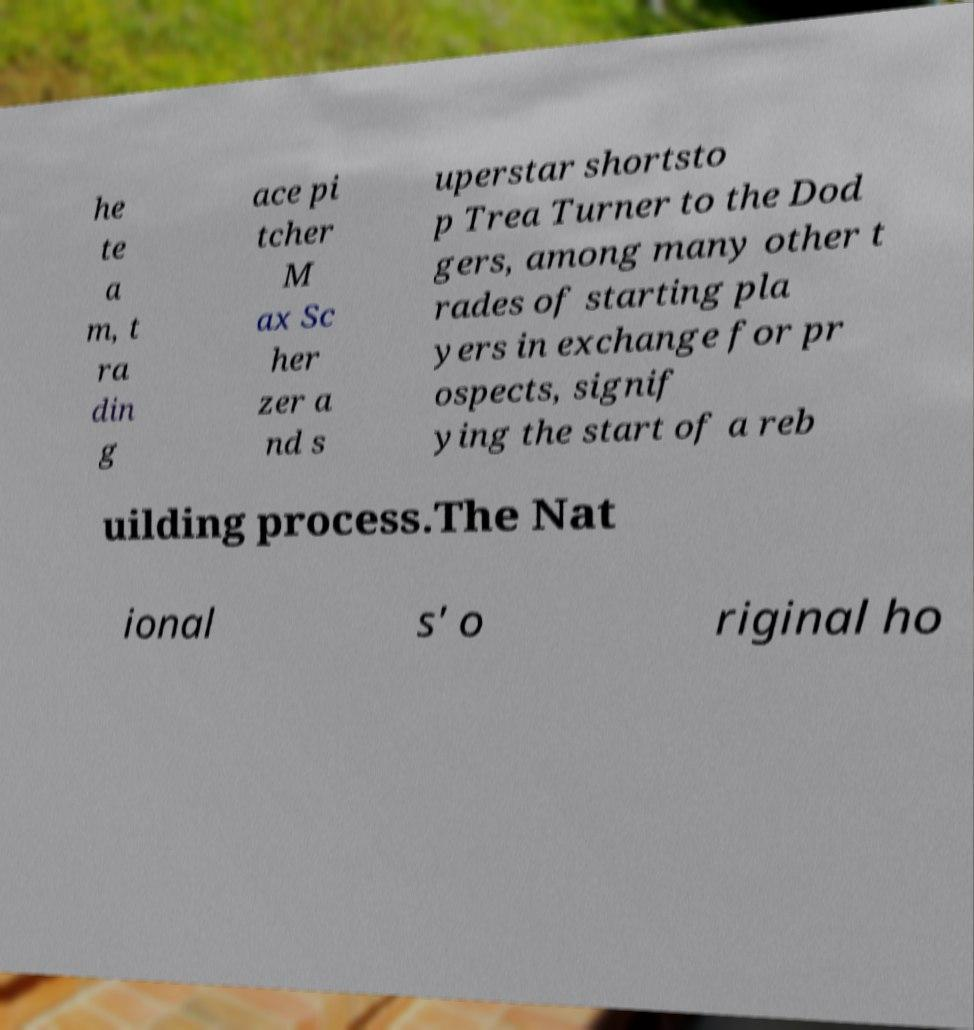I need the written content from this picture converted into text. Can you do that? he te a m, t ra din g ace pi tcher M ax Sc her zer a nd s uperstar shortsto p Trea Turner to the Dod gers, among many other t rades of starting pla yers in exchange for pr ospects, signif ying the start of a reb uilding process.The Nat ional s' o riginal ho 